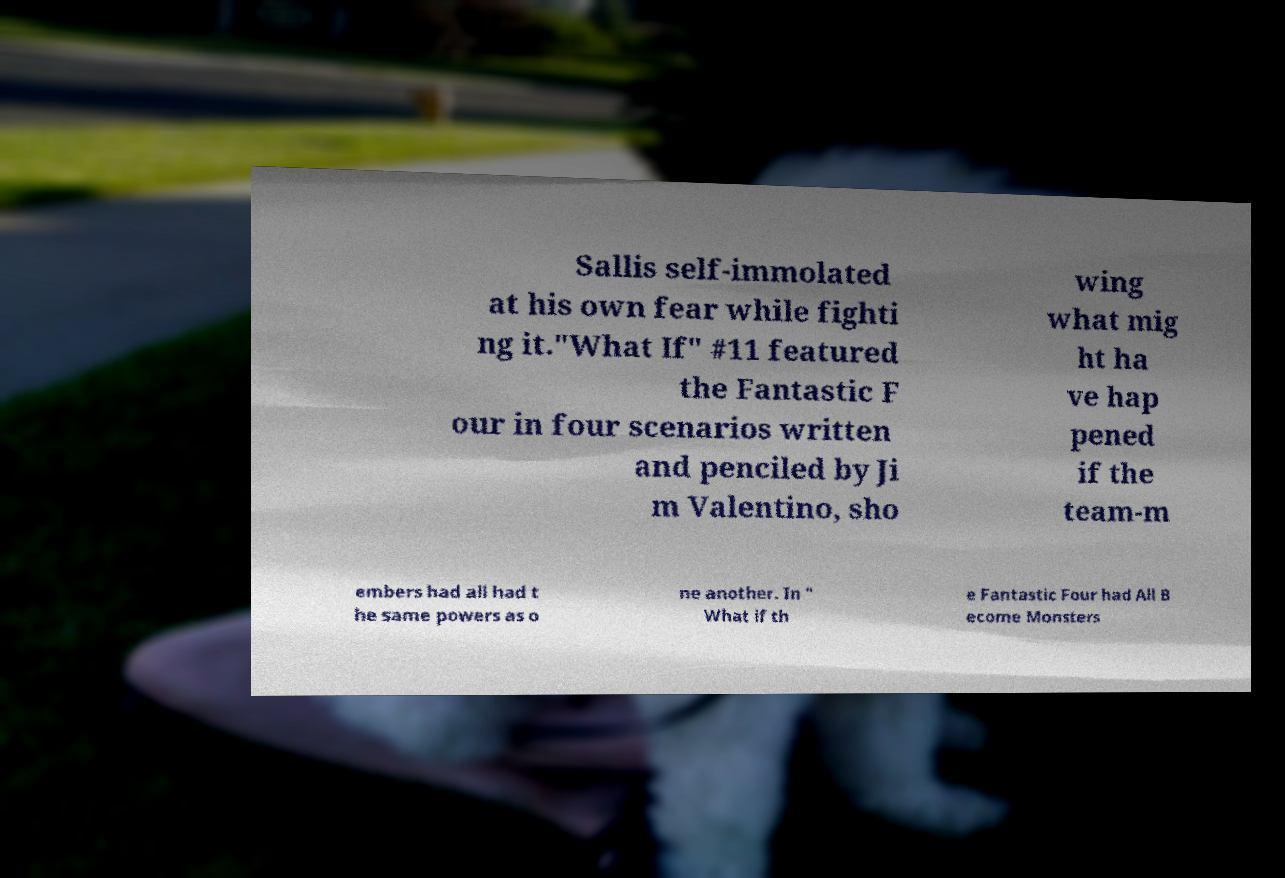What messages or text are displayed in this image? I need them in a readable, typed format. Sallis self-immolated at his own fear while fighti ng it."What If" #11 featured the Fantastic F our in four scenarios written and penciled by Ji m Valentino, sho wing what mig ht ha ve hap pened if the team-m embers had all had t he same powers as o ne another. In " What if th e Fantastic Four had All B ecome Monsters 